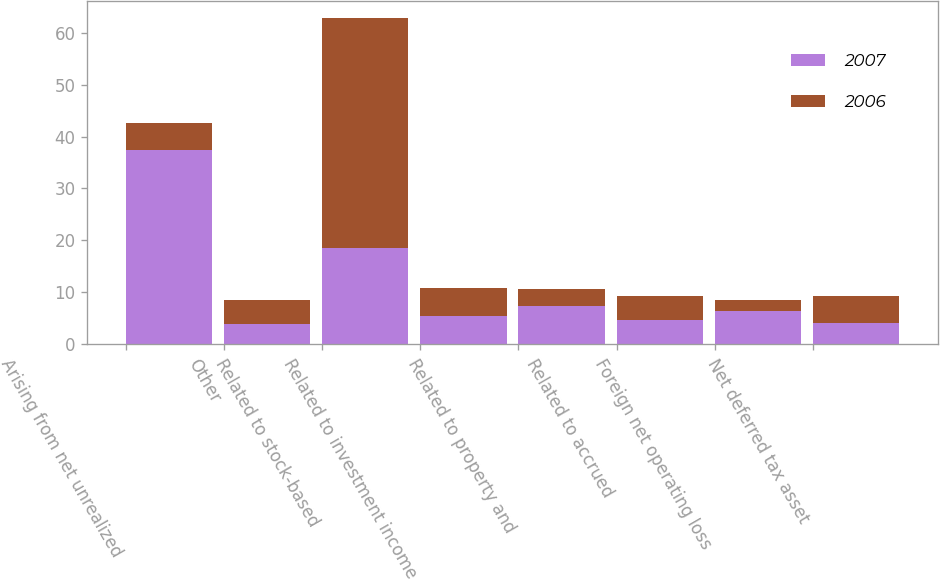Convert chart to OTSL. <chart><loc_0><loc_0><loc_500><loc_500><stacked_bar_chart><ecel><fcel>Arising from net unrealized<fcel>Other<fcel>Related to stock-based<fcel>Related to investment income<fcel>Related to property and<fcel>Related to accrued<fcel>Foreign net operating loss<fcel>Net deferred tax asset<nl><fcel>2007<fcel>37.5<fcel>3.8<fcel>18.6<fcel>5.4<fcel>7.3<fcel>4.7<fcel>6.3<fcel>4<nl><fcel>2006<fcel>5.2<fcel>4.7<fcel>44.3<fcel>5.4<fcel>3.3<fcel>4.5<fcel>2.2<fcel>5.2<nl></chart> 